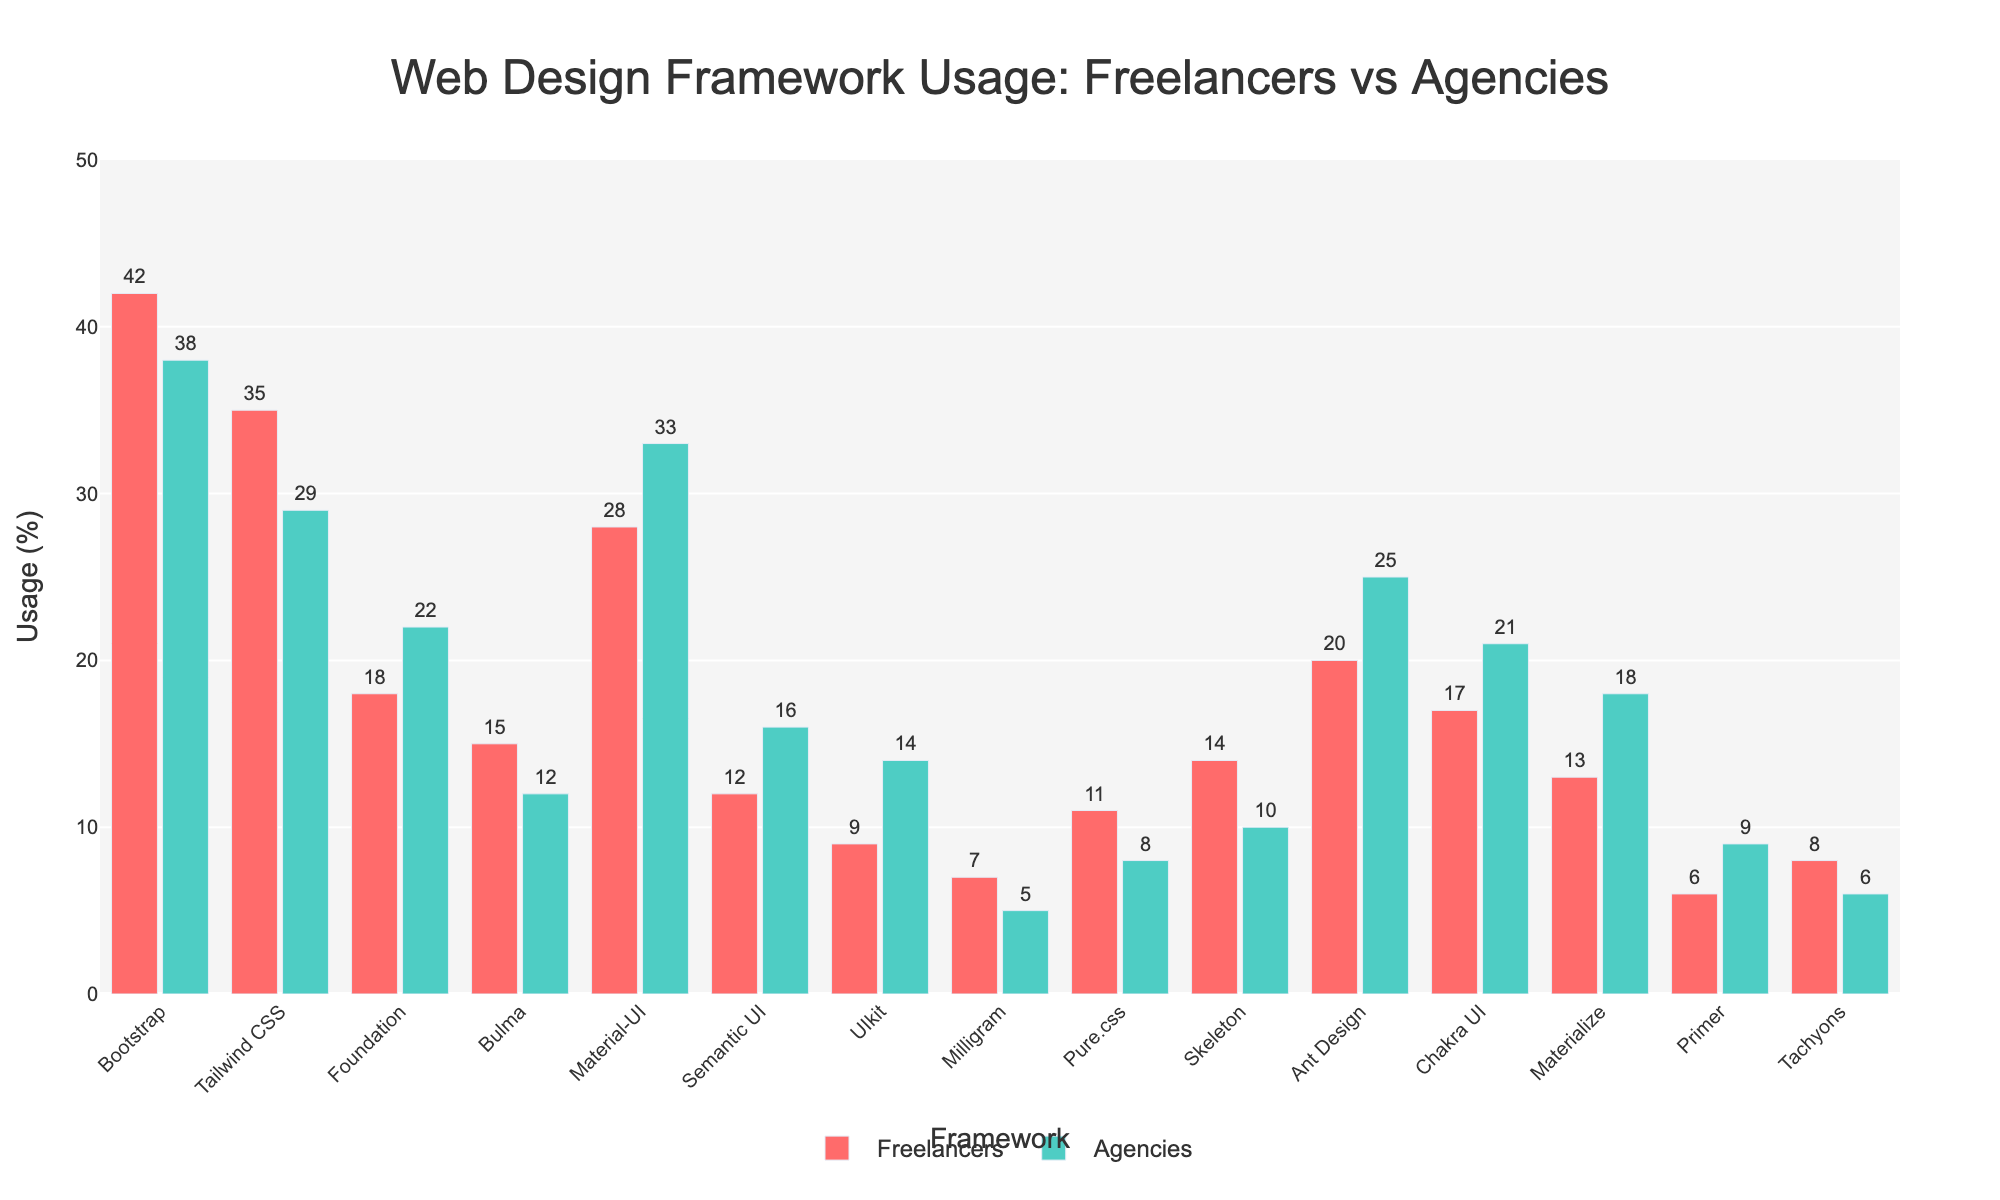Which framework has the highest usage among freelancers? Look for the tallest red bar representing freelancers. Bootstrap has the highest percentage at 42%.
Answer: Bootstrap Which framework shows a higher usage percentage by agencies than by freelancers? Compare the height of each pair of bars for freelancers and agencies. Material-UI, Foundation, Semantic UI, UIkit, Ant Design, Chakra UI, Materialize, and Primer all have higher agency usage than freelancer usage.
Answer: Material-UI, Foundation, Semantic UI, UIkit, Ant Design, Chakra UI, Materialize, Primer What is the difference in usage percentage of Material-UI between freelancers and agencies? Find the bars for Material-UI and subtract the freelancers' percentage (28%) from the agencies' percentage (33%). The calculation is 33% - 28% = 5%.
Answer: 5% Which framework has the closest usage percentages between freelancers and agencies? Compare the height of the bars for each framework and find the smallest difference. Bootstrap (42% and 38%) and Bulma (15% and 12%) have a difference of 4% and 3% respectively. The closest is Bulma with a difference of 3%.
Answer: Bulma On average, do freelancers or agencies use more frameworks listed in the chart? Calculate the average usage percentage for freelancers and agencies. Sum the percentages for freelancers and divide by the number of frameworks (15), and do the same for agencies. Freelancers: (42+35+18+15+28+12+9+7+11+14+20+17+13+6+8)/15 = 17.6, Agencies: (38+29+22+12+33+16+14+5+8+10+25+21+18+9+6)/15 = 17.4. Freelancers' average is slightly higher.
Answer: Freelancers Among freelancers, which framework has the second lowest usage percentage? Look for the second shortest red bar representing freelancers. Milligram has the lowest (7%), and Primer is the second lowest (6%).
Answer: Primer For which framework is the difference in usage between freelancers and agencies the largest? Calculate the absolute difference for each framework. Bootstrap has a difference of 4%, Tailwind CSS is 6%, Foundation is 4%, Bulma is 3%, Material-UI is 5%, Semantic UI is 4%, UIkit is 5%, Milligram is 2%, Pure.css is 3%, Skeleton is 4%, Ant Design is 5%, Chakra UI is 4%, Materialize is 5%, Primer is 3%, and Tachyons is 2%. The largest difference is for Tailwind CSS, which is 6%.
Answer: Tailwind CSS What is the combined usage percentage of Bootstrap, Tailwind CSS, and Material-UI among agencies? Add the percentages for each framework in the agencies' column: 38% (Bootstrap) + 29% (Tailwind CSS) + 33% (Material-UI) = 100%.
Answer: 100% 